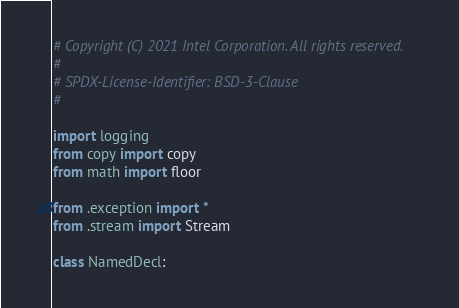<code> <loc_0><loc_0><loc_500><loc_500><_Python_># Copyright (C) 2021 Intel Corporation. All rights reserved.
#
# SPDX-License-Identifier: BSD-3-Clause
#

import logging
from copy import copy
from math import floor

from .exception import *
from .stream import Stream

class NamedDecl:</code> 